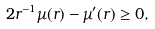<formula> <loc_0><loc_0><loc_500><loc_500>2 r ^ { - 1 } \mu ( r ) - \mu ^ { \prime } ( r ) \geq 0 ,</formula> 